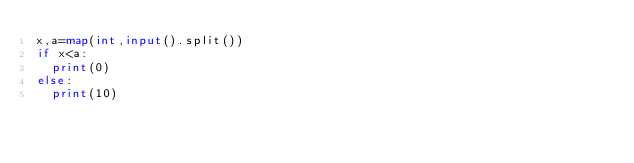<code> <loc_0><loc_0><loc_500><loc_500><_Python_>x,a=map(int,input().split())
if x<a:
  print(0)
else:
  print(10)</code> 